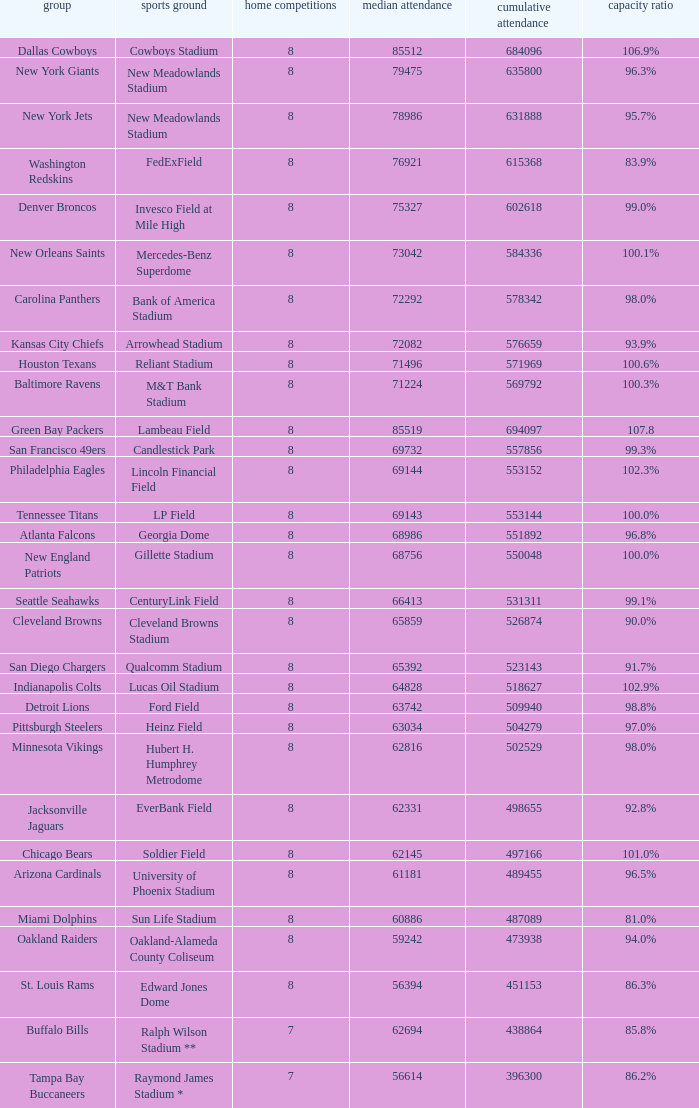What is the number listed in home games when the team is Seattle Seahawks? 8.0. Can you parse all the data within this table? {'header': ['group', 'sports ground', 'home competitions', 'median attendance', 'cumulative attendance', 'capacity ratio'], 'rows': [['Dallas Cowboys', 'Cowboys Stadium', '8', '85512', '684096', '106.9%'], ['New York Giants', 'New Meadowlands Stadium', '8', '79475', '635800', '96.3%'], ['New York Jets', 'New Meadowlands Stadium', '8', '78986', '631888', '95.7%'], ['Washington Redskins', 'FedExField', '8', '76921', '615368', '83.9%'], ['Denver Broncos', 'Invesco Field at Mile High', '8', '75327', '602618', '99.0%'], ['New Orleans Saints', 'Mercedes-Benz Superdome', '8', '73042', '584336', '100.1%'], ['Carolina Panthers', 'Bank of America Stadium', '8', '72292', '578342', '98.0%'], ['Kansas City Chiefs', 'Arrowhead Stadium', '8', '72082', '576659', '93.9%'], ['Houston Texans', 'Reliant Stadium', '8', '71496', '571969', '100.6%'], ['Baltimore Ravens', 'M&T Bank Stadium', '8', '71224', '569792', '100.3%'], ['Green Bay Packers', 'Lambeau Field', '8', '85519', '694097', '107.8'], ['San Francisco 49ers', 'Candlestick Park', '8', '69732', '557856', '99.3%'], ['Philadelphia Eagles', 'Lincoln Financial Field', '8', '69144', '553152', '102.3%'], ['Tennessee Titans', 'LP Field', '8', '69143', '553144', '100.0%'], ['Atlanta Falcons', 'Georgia Dome', '8', '68986', '551892', '96.8%'], ['New England Patriots', 'Gillette Stadium', '8', '68756', '550048', '100.0%'], ['Seattle Seahawks', 'CenturyLink Field', '8', '66413', '531311', '99.1%'], ['Cleveland Browns', 'Cleveland Browns Stadium', '8', '65859', '526874', '90.0%'], ['San Diego Chargers', 'Qualcomm Stadium', '8', '65392', '523143', '91.7%'], ['Indianapolis Colts', 'Lucas Oil Stadium', '8', '64828', '518627', '102.9%'], ['Detroit Lions', 'Ford Field', '8', '63742', '509940', '98.8%'], ['Pittsburgh Steelers', 'Heinz Field', '8', '63034', '504279', '97.0%'], ['Minnesota Vikings', 'Hubert H. Humphrey Metrodome', '8', '62816', '502529', '98.0%'], ['Jacksonville Jaguars', 'EverBank Field', '8', '62331', '498655', '92.8%'], ['Chicago Bears', 'Soldier Field', '8', '62145', '497166', '101.0%'], ['Arizona Cardinals', 'University of Phoenix Stadium', '8', '61181', '489455', '96.5%'], ['Miami Dolphins', 'Sun Life Stadium', '8', '60886', '487089', '81.0%'], ['Oakland Raiders', 'Oakland-Alameda County Coliseum', '8', '59242', '473938', '94.0%'], ['St. Louis Rams', 'Edward Jones Dome', '8', '56394', '451153', '86.3%'], ['Buffalo Bills', 'Ralph Wilson Stadium **', '7', '62694', '438864', '85.8%'], ['Tampa Bay Buccaneers', 'Raymond James Stadium *', '7', '56614', '396300', '86.2%']]} 